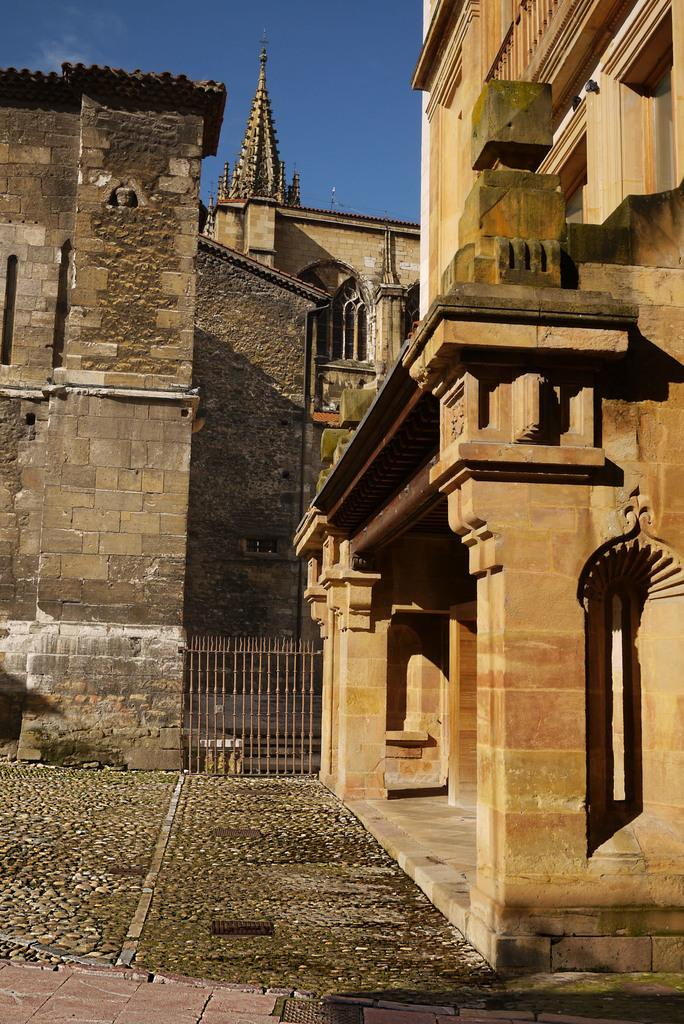What type of structures can be seen in the image? There are buildings in the image. What is the entrance to the area in the image? There is a gate in the image. What else can be seen in the image besides buildings and the gate? There are other objects in the image. What is visible at the bottom of the image? The floor is visible at the bottom of the image. What is visible in the background of the image? The sky is visible in the background of the image. What type of plant is being cooked in the image? There is no plant being cooked in the image. What type of drug is visible in the image? There is no drug present in the image. 